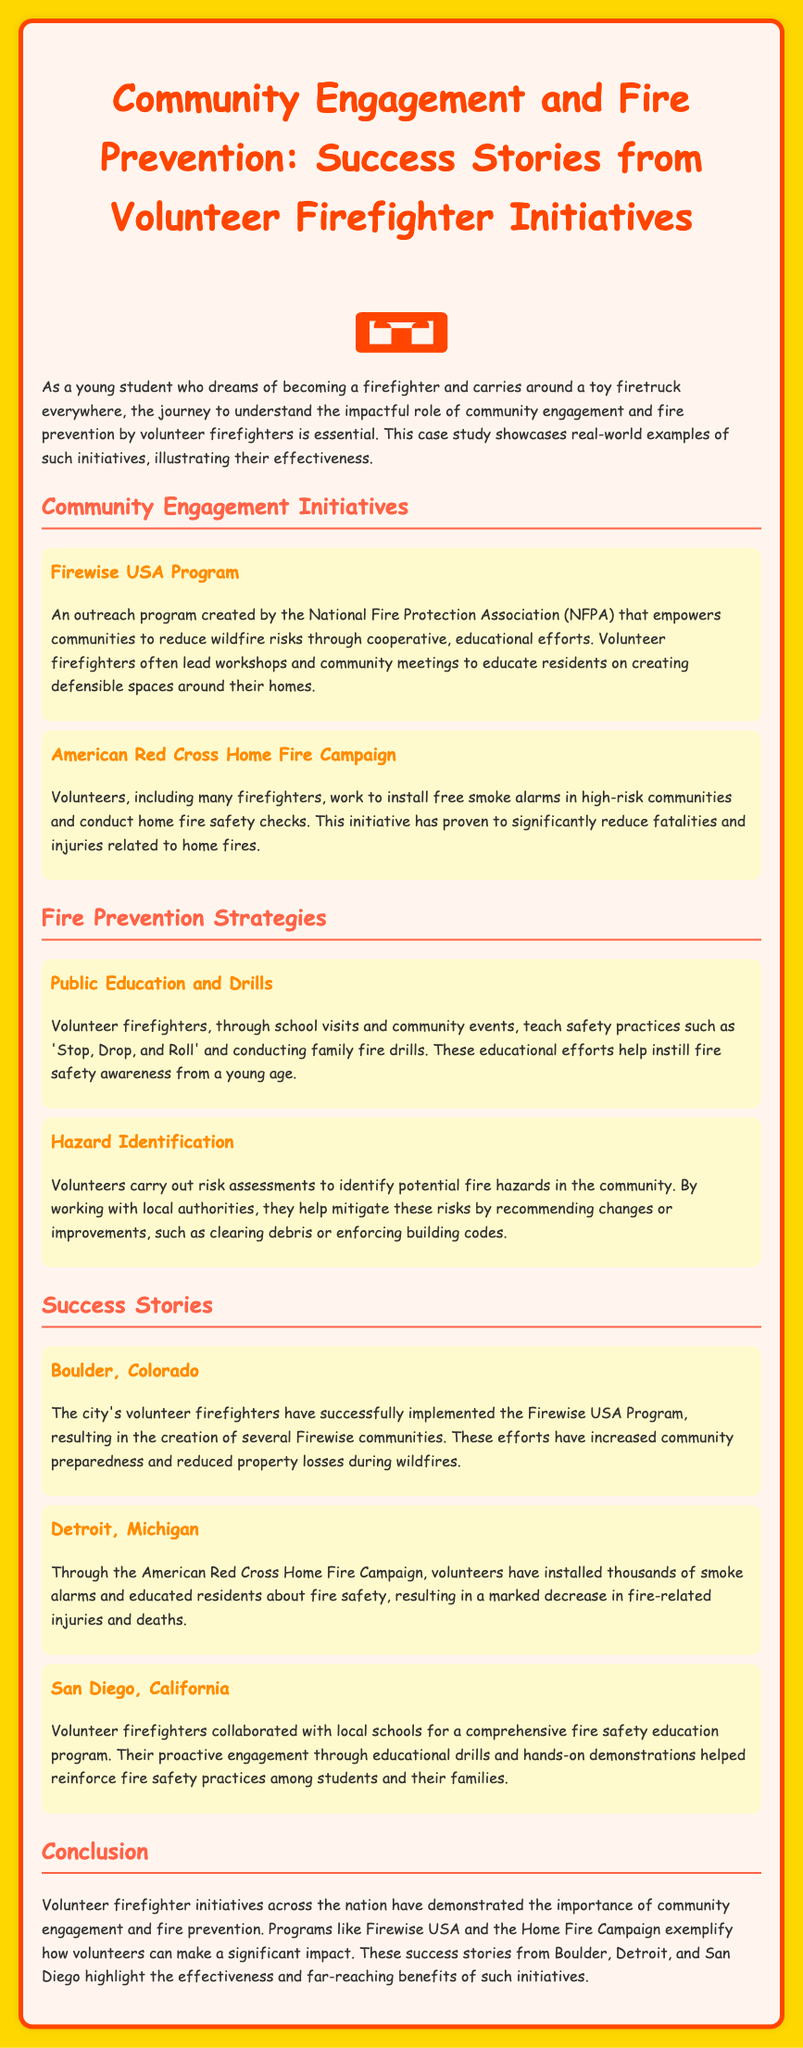What is the name of the first community engagement initiative mentioned? The first community engagement initiative listed in the document is the Firewise USA Program.
Answer: Firewise USA Program Which city implemented the Firewise USA Program successfully? Boulder, Colorado is noted for successfully implementing the Firewise USA Program.
Answer: Boulder, Colorado What safety practice is taught through public education and drills? The document mentions 'Stop, Drop, and Roll' as a safety practice taught during these events.
Answer: Stop, Drop, and Roll How many smoke alarms were installed through the American Red Cross Home Fire Campaign in Detroit? The document states that volunteers have installed thousands of smoke alarms in the community.
Answer: Thousands What is a key outcome of the American Red Cross Home Fire Campaign? The campaign has resulted in a marked decrease in fire-related injuries and deaths.
Answer: Decrease in injuries and deaths What role do volunteer firefighters play in hazard identification? Volunteer firefighters conduct risk assessments to identify potential fire hazards in the community.
Answer: Conduct risk assessments How are success stories from different cities categorized in the document? The success stories are categorized under the heading "Success Stories."
Answer: Success Stories What advantage does the Firewise USA Program provide? The program increases community preparedness and reduces property losses during wildfires.
Answer: Increases community preparedness In which city did volunteer firefighters work with local schools for fire safety education? San Diego, California is where volunteer firefighters collaborated with local schools for fire safety education.
Answer: San Diego, California What common goal do all the initiatives in the document share? All initiatives aim to enhance community engagement and improve fire prevention efforts.
Answer: Enhance community engagement and improve fire prevention 